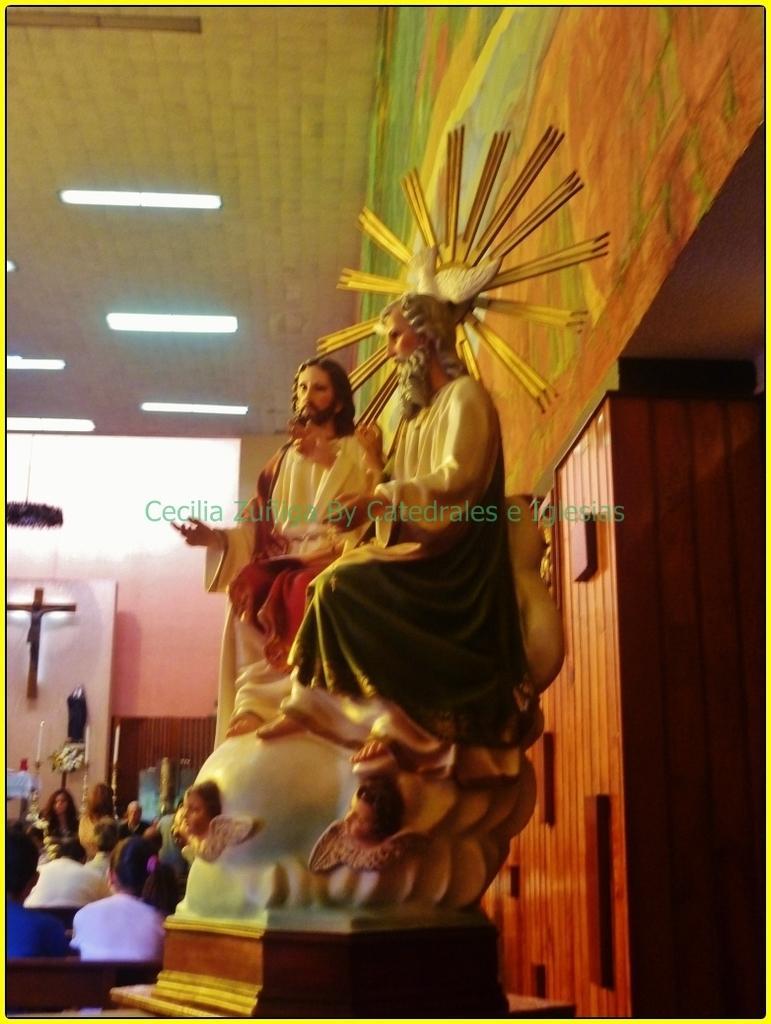Can you describe this image briefly? This is an edited image. I can see the sculpture of two persons. At the bottom left side of the image, I can see a group of people and a holy cross symbol attached to the wall. There are ceiling lights attached to the ceiling. On the right side of the image, I can see a wooden wall and a poster. At the center of the image, I can see the watermark. 